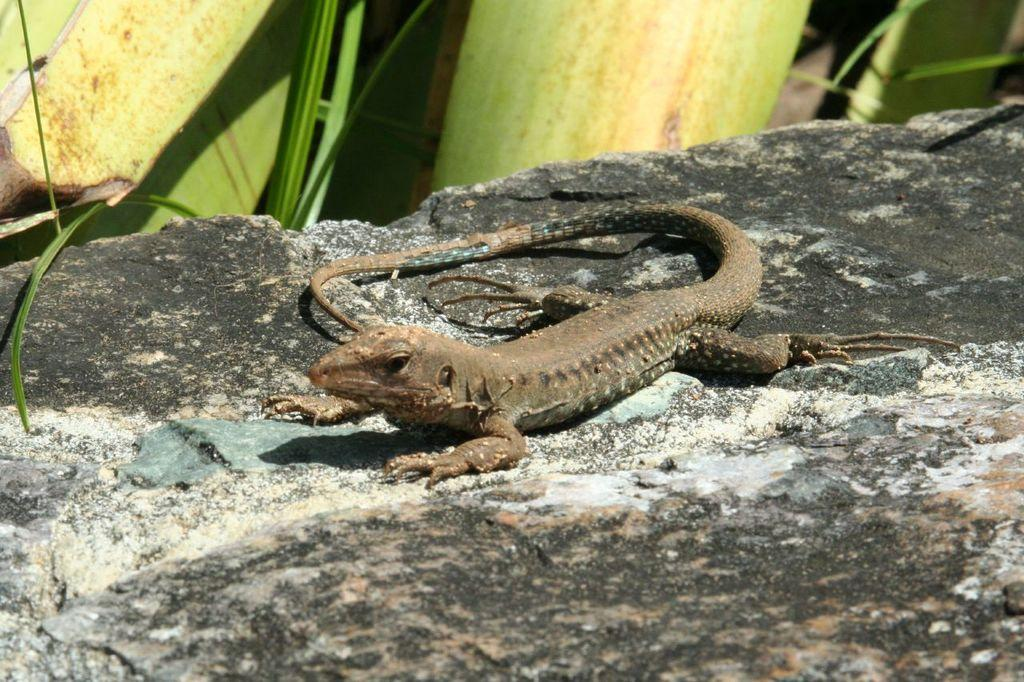What type of animal can be seen on the path in the image? There is a lizard on the path in the image. What can be seen in the background of the image? There are leaves visible in the background of the image. How many cars are parked near the lizard in the image? There are no cars present in the image; it features a lizard on a path with leaves in the background. What type of bear can be seen in the image? There is no bear present in the image; it features a lizard on a path with leaves in the background. 